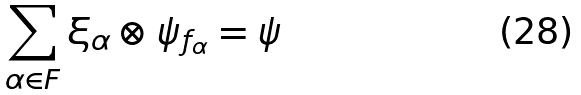<formula> <loc_0><loc_0><loc_500><loc_500>\sum _ { \alpha \in F } \xi _ { \alpha } \otimes \psi _ { f _ { \alpha } } = \psi</formula> 